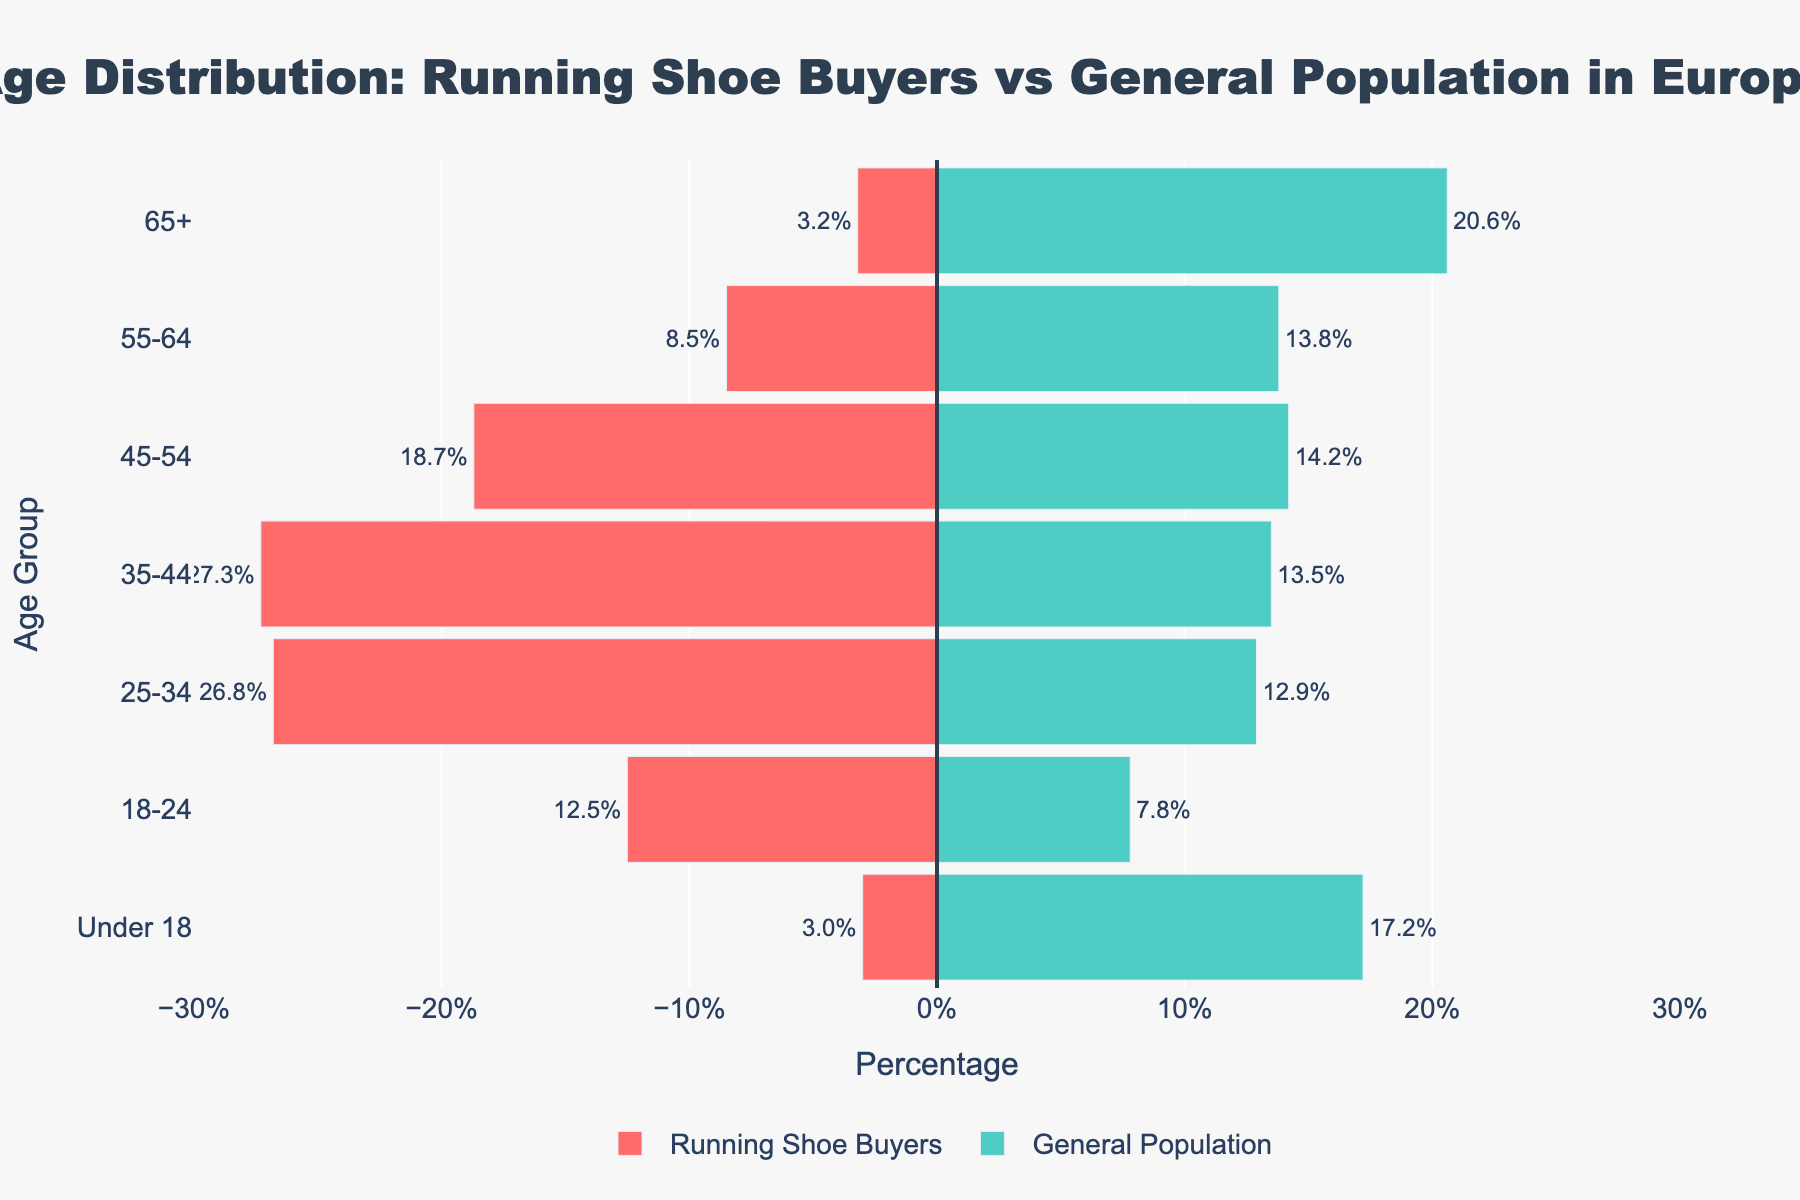What's the title of the figure? The title is located at the top of the figure and provides a summary of what the graph represents. It reads "Age Distribution: Running Shoe Buyers vs General Population in Europe".
Answer: Age Distribution: Running Shoe Buyers vs General Population in Europe How many age groups are represented in the figure? The figure lists the age groups along the y-axis, with each group labeled separately. Count these groups to find there are seven age groups.
Answer: Seven Which age group has the highest percentage of running shoe buyers? By looking at the bars on the left side of the zero line (representing running shoe buyers), the longest bar corresponds to the age group 35-44 with 27.3%.
Answer: 35-44 What is the percentage of running shoe buyers in the 55-64 age group? Look at the horizontal bar representing the 55-64 age group on the left side of the figure, the percentage is labeled as 8.5%.
Answer: 8.5% How does the percentage of running shoe buyers in the 18-24 age group compare to the general population in the same age group? By comparing the lengths of the bars for the 18-24 age group on both sides of the vertical line, the running shoe buyers bar is longer, with 12.5% compared to the general population's 7.8%.
Answer: 12.5% vs. 7.8% Which age group has the smallest difference in percentage between running shoe buyers and the general population? For each age group, subtract the percentage of the general population from the percentage of running shoe buyers. The age group with the smallest absolute difference is the 55-64 group with a difference of 5.3% (8.5% - 13.8%).
Answer: 55-64 What is the combined percentage of running shoe buyers in the 35-44 and 25-34 age groups? Add the percentages of the running shoe buyers for these two groups: 27.3% (35-44) + 26.8% (25-34) = 54.1%.
Answer: 54.1% In which age group is the percentage of the general population higher than the percentage of running shoe buyers? Compare the bars for each age group. The general population percentage is higher than that of running shoe buyers in the age groups 65+ (20.6% vs. 3.2%) and Under 18 (17.2% vs. 3.0%).
Answer: 65+ and Under 18 What is the average percentage of running shoe buyers across all age groups? Sum the percentages of running shoe buyers for all age groups and divide by the number of age groups: (3.2 + 8.5 + 18.7 + 27.3 + 26.8 + 12.5 + 3.0)/7 = 14.3%.
Answer: 14.3% What trend can you observe about the age distribution of running shoe buyers compared to the general population? The running shoe buyers are more concentrated in the middle age groups (25-44), whereas the general population has a more balanced distribution with higher percentages in the younger and older age groups. The trend shows that running shoe buyers are typically younger adults.
Answer: Concentrated in 25-44 age groups 